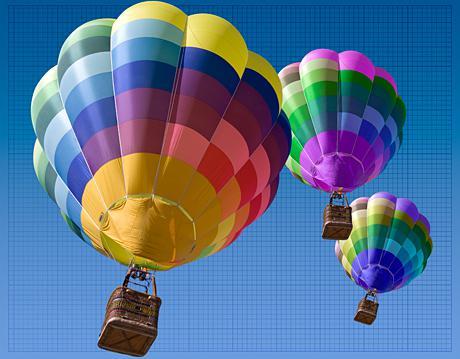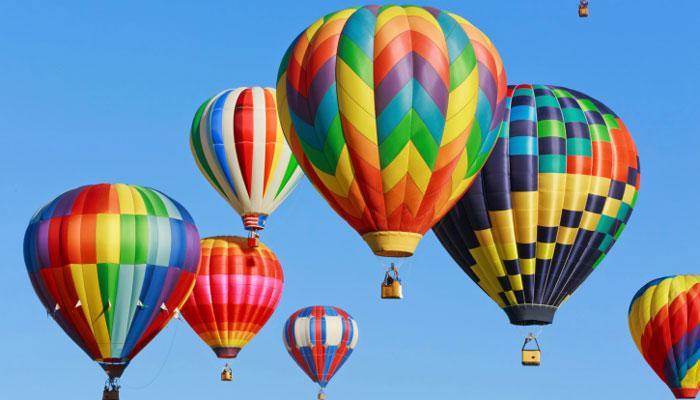The first image is the image on the left, the second image is the image on the right. Examine the images to the left and right. Is the description "There is a skydiver in the image on the right." accurate? Answer yes or no. No. 